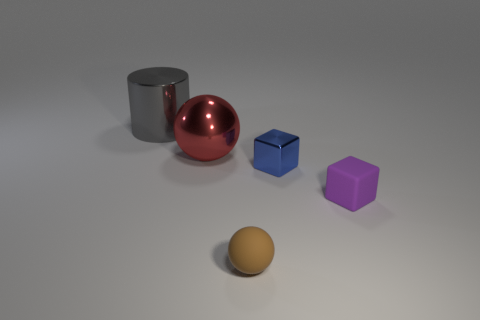Subtract all purple blocks. How many blocks are left? 1 Add 2 big gray matte balls. How many objects exist? 7 Add 1 big metal objects. How many big metal objects exist? 3 Subtract 1 brown balls. How many objects are left? 4 Subtract all blocks. How many objects are left? 3 Subtract all big gray cylinders. Subtract all purple rubber objects. How many objects are left? 3 Add 5 big gray shiny cylinders. How many big gray shiny cylinders are left? 6 